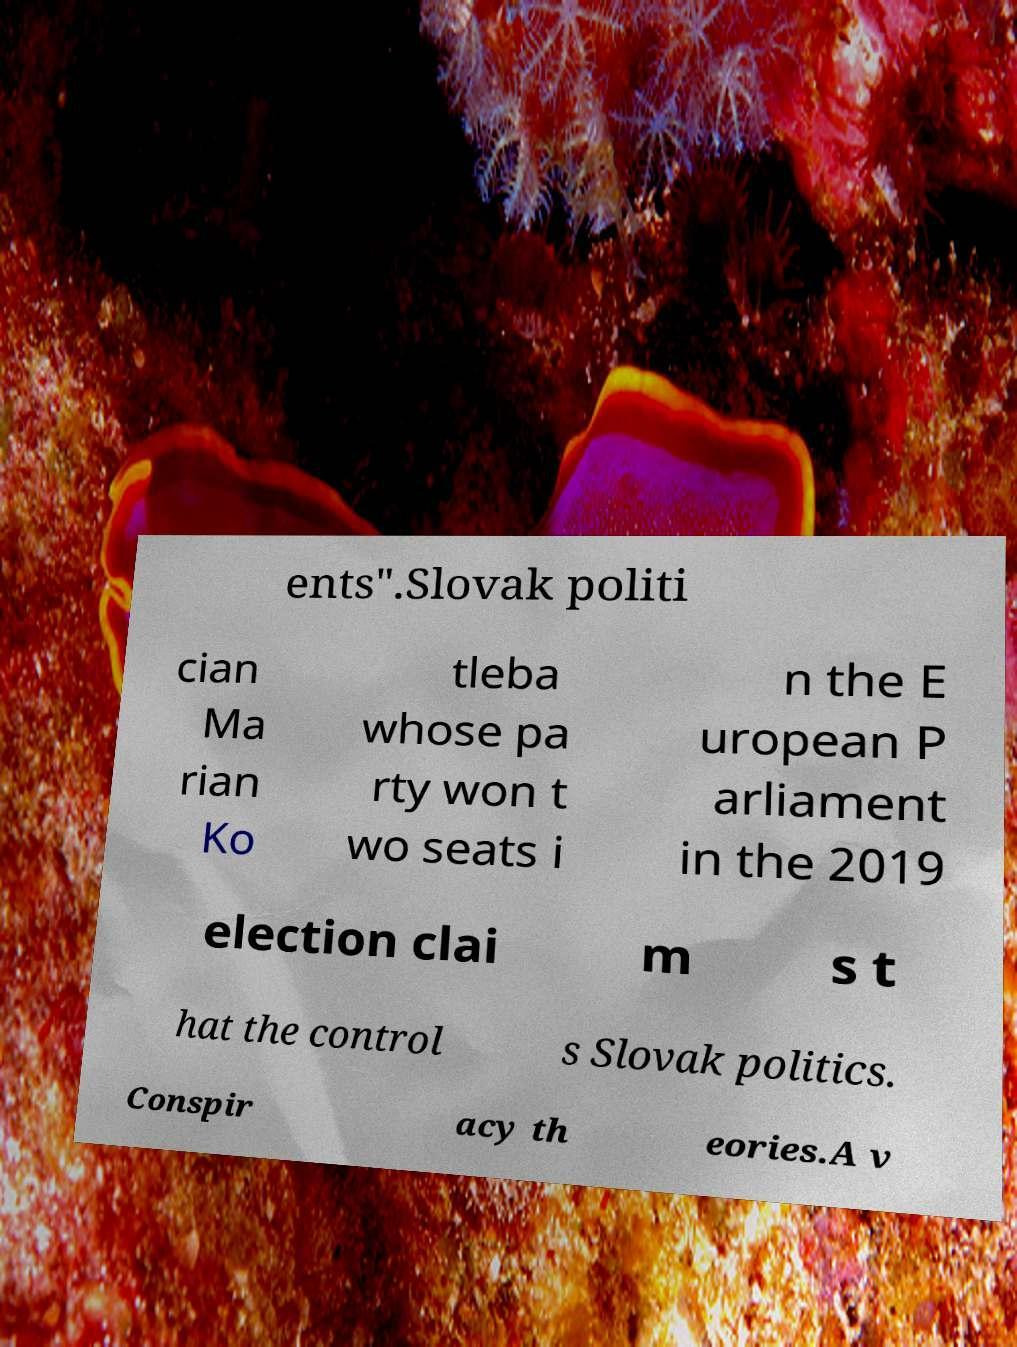What messages or text are displayed in this image? I need them in a readable, typed format. ents".Slovak politi cian Ma rian Ko tleba whose pa rty won t wo seats i n the E uropean P arliament in the 2019 election clai m s t hat the control s Slovak politics. Conspir acy th eories.A v 